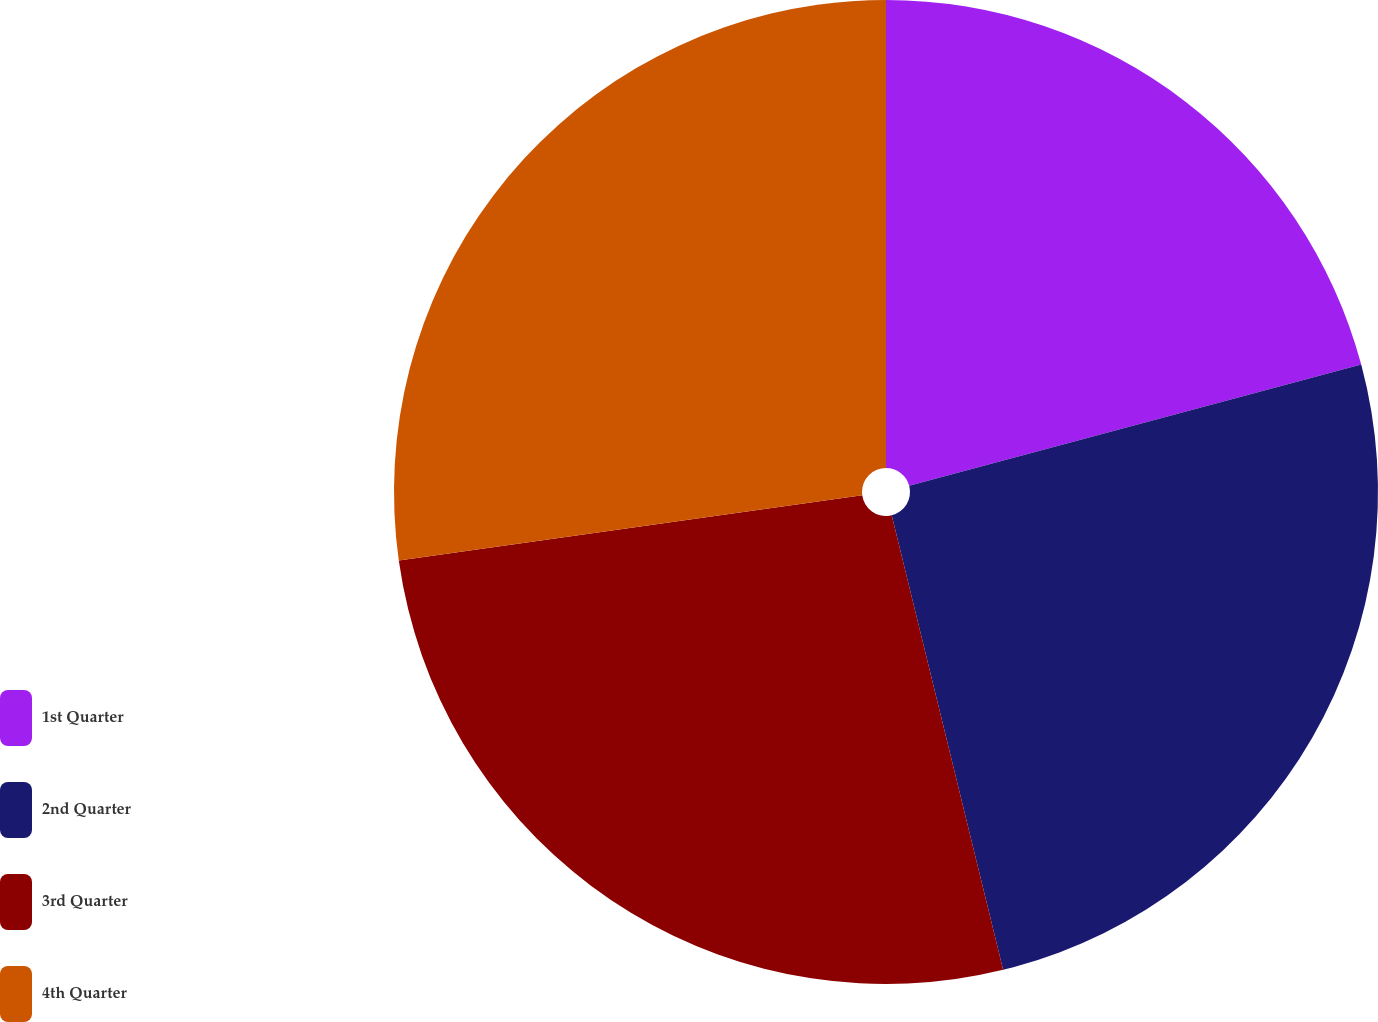<chart> <loc_0><loc_0><loc_500><loc_500><pie_chart><fcel>1st Quarter<fcel>2nd Quarter<fcel>3rd Quarter<fcel>4th Quarter<nl><fcel>20.83%<fcel>25.34%<fcel>26.6%<fcel>27.22%<nl></chart> 